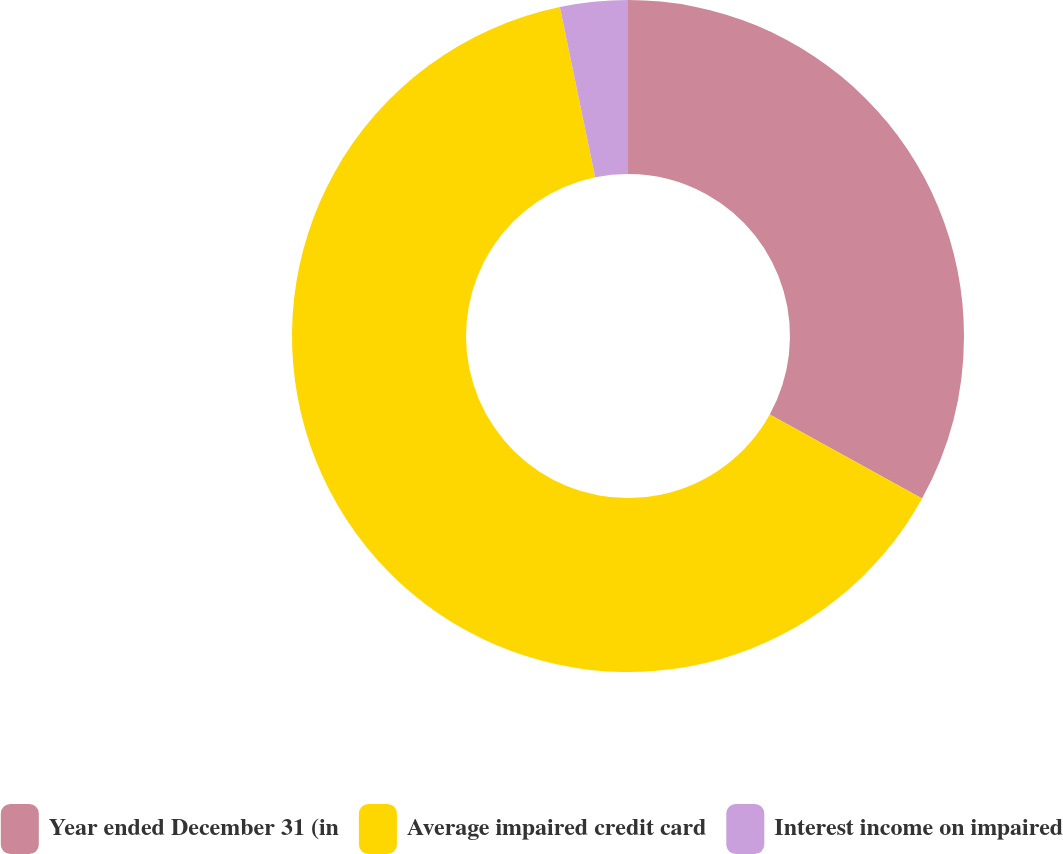<chart> <loc_0><loc_0><loc_500><loc_500><pie_chart><fcel>Year ended December 31 (in<fcel>Average impaired credit card<fcel>Interest income on impaired<nl><fcel>33.04%<fcel>63.71%<fcel>3.25%<nl></chart> 